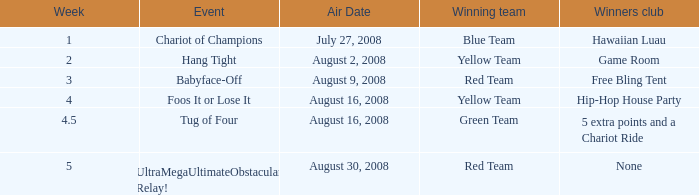Which Week has an Air Date of august 30, 2008? 5.0. 